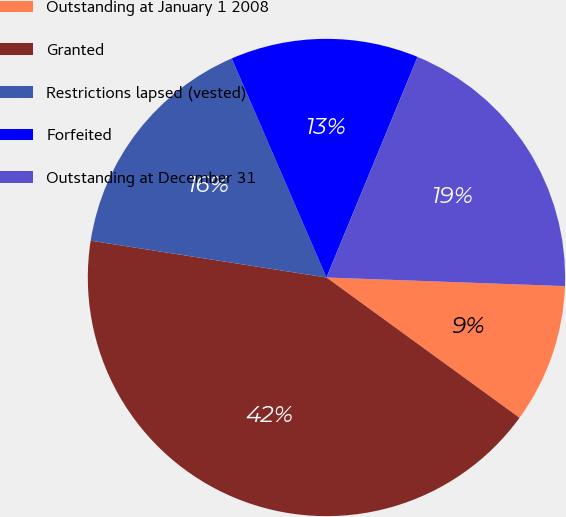Convert chart. <chart><loc_0><loc_0><loc_500><loc_500><pie_chart><fcel>Outstanding at January 1 2008<fcel>Granted<fcel>Restrictions lapsed (vested)<fcel>Forfeited<fcel>Outstanding at December 31<nl><fcel>9.43%<fcel>42.46%<fcel>16.04%<fcel>12.73%<fcel>19.34%<nl></chart> 